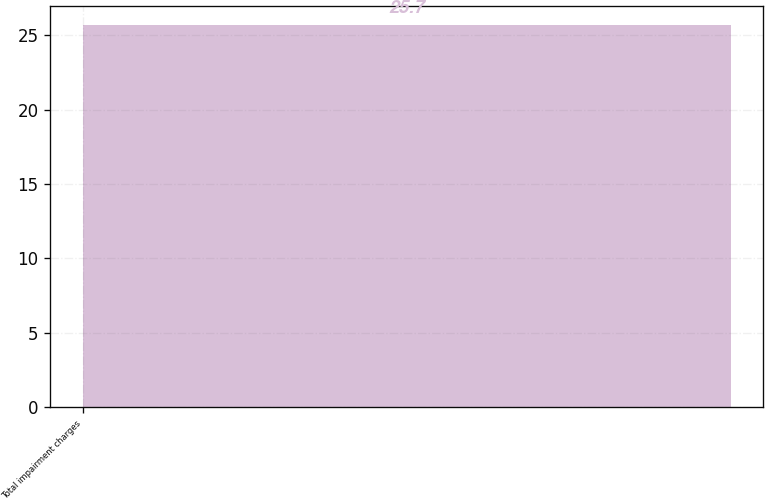<chart> <loc_0><loc_0><loc_500><loc_500><bar_chart><fcel>Total impairment charges<nl><fcel>25.7<nl></chart> 